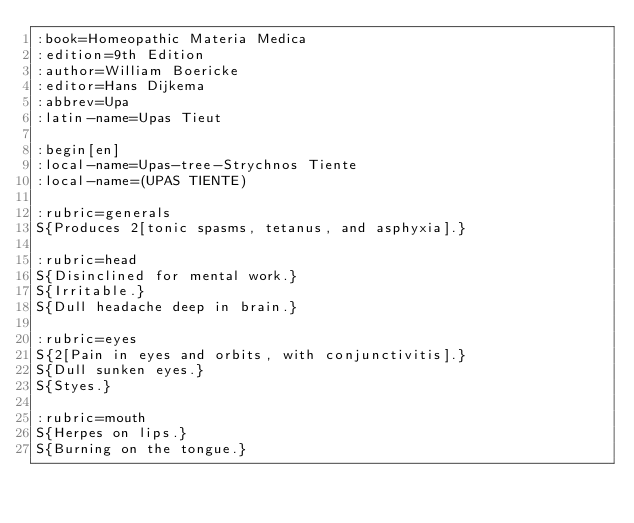Convert code to text. <code><loc_0><loc_0><loc_500><loc_500><_ObjectiveC_>:book=Homeopathic Materia Medica
:edition=9th Edition
:author=William Boericke
:editor=Hans Dijkema
:abbrev=Upa
:latin-name=Upas Tieut

:begin[en]
:local-name=Upas-tree-Strychnos Tiente
:local-name=(UPAS TIENTE)

:rubric=generals
S{Produces 2[tonic spasms, tetanus, and asphyxia].}

:rubric=head
S{Disinclined for mental work.}
S{Irritable.}
S{Dull headache deep in brain.}

:rubric=eyes
S{2[Pain in eyes and orbits, with conjunctivitis].}
S{Dull sunken eyes.}
S{Styes.}

:rubric=mouth
S{Herpes on lips.}
S{Burning on the tongue.}</code> 